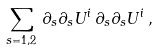<formula> <loc_0><loc_0><loc_500><loc_500>\sum _ { s = 1 , 2 } \, { \partial } _ { s } { \partial } _ { s } U ^ { i } \, { \partial } _ { s } { \partial } _ { s } U ^ { i } \, ,</formula> 